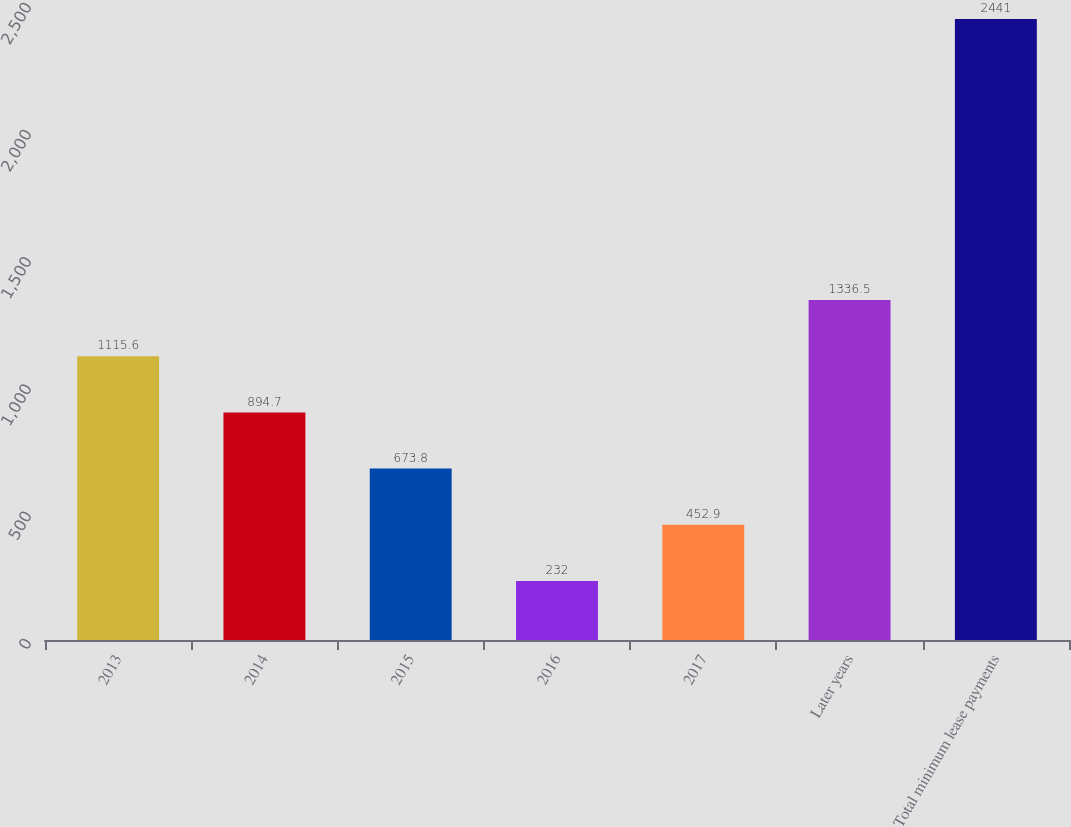Convert chart to OTSL. <chart><loc_0><loc_0><loc_500><loc_500><bar_chart><fcel>2013<fcel>2014<fcel>2015<fcel>2016<fcel>2017<fcel>Later years<fcel>Total minimum lease payments<nl><fcel>1115.6<fcel>894.7<fcel>673.8<fcel>232<fcel>452.9<fcel>1336.5<fcel>2441<nl></chart> 